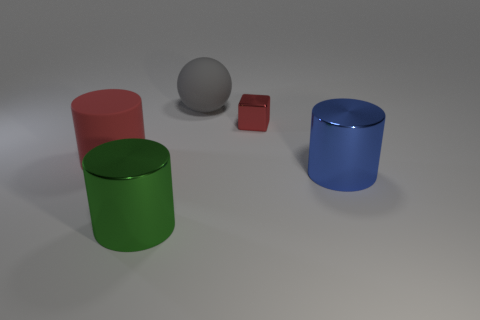Which object in the image looks like it has the roughest texture? The objects in the image appear to have varying textures. The red cylinder and the small red cube have a reflective, possibly metallic finish, indicating a smoother surface. The green and blue cylinders have a more subdued, less reflective finish, which could suggest a rougher texture. However, without tactile examination, it's difficult to determine the absolute roughest texture just from the visual. 